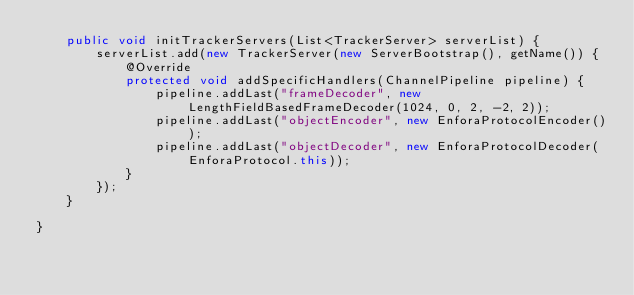Convert code to text. <code><loc_0><loc_0><loc_500><loc_500><_Java_>    public void initTrackerServers(List<TrackerServer> serverList) {
        serverList.add(new TrackerServer(new ServerBootstrap(), getName()) {
            @Override
            protected void addSpecificHandlers(ChannelPipeline pipeline) {
                pipeline.addLast("frameDecoder", new LengthFieldBasedFrameDecoder(1024, 0, 2, -2, 2));
                pipeline.addLast("objectEncoder", new EnforaProtocolEncoder());
                pipeline.addLast("objectDecoder", new EnforaProtocolDecoder(EnforaProtocol.this));
            }
        });
    }

}
</code> 